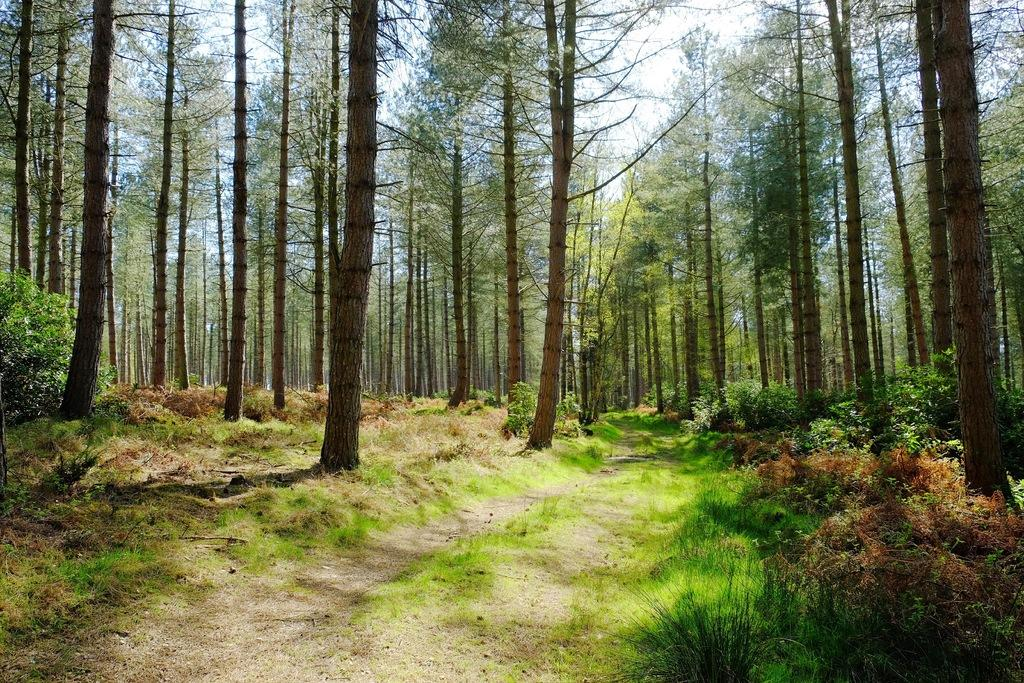What type of vegetation can be seen in the image? There is grass, plants, and trees in the image. What can be seen in the background of the image? The sky is visible in the background of the image. Are there any rings visible on the seashore in the image? There is no seashore present in the image, and therefore no rings can be seen. 